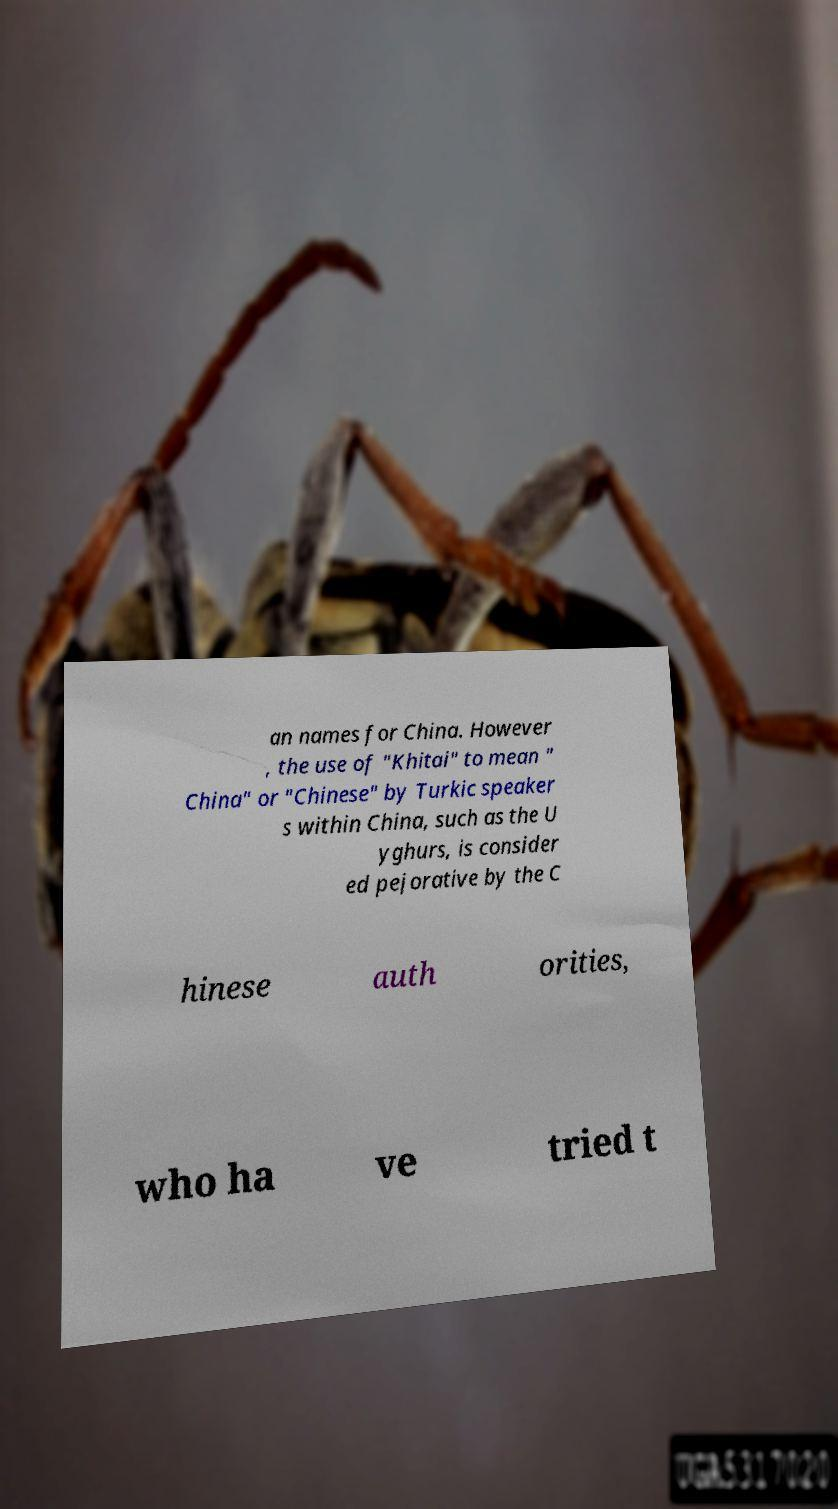Please identify and transcribe the text found in this image. an names for China. However , the use of "Khitai" to mean " China" or "Chinese" by Turkic speaker s within China, such as the U yghurs, is consider ed pejorative by the C hinese auth orities, who ha ve tried t 